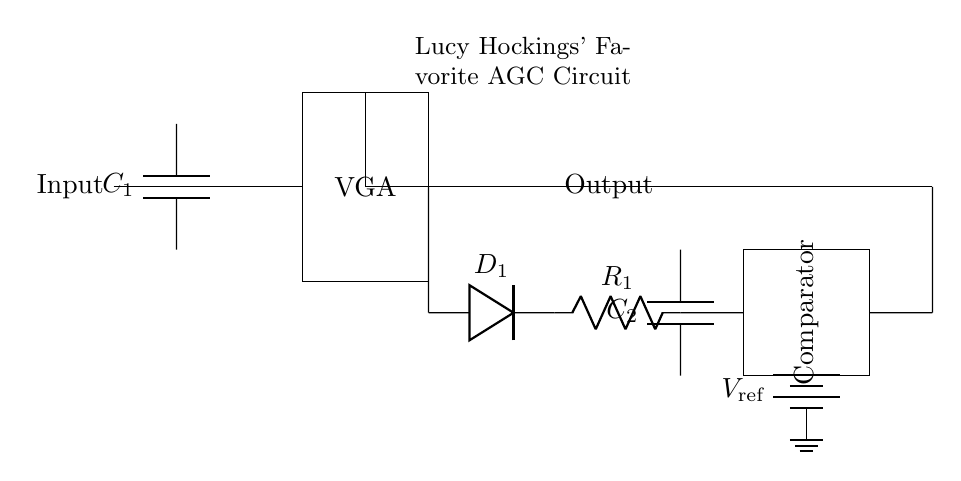What type of circuit is depicted? The circuit is an automatic gain control circuit, which is indicated by the variable gain amplifier and the feedback mechanisms present in the diagram.
Answer: Automatic gain control circuit What component is used to filter the signal? The component used for filtering the signal is a capacitor. In the circuit, the capacitor labeled C1 is connected in parallel with the input to help manage signal levels.
Answer: Capacitor How many main components are depicted in the circuit diagram? The circuit consists of six main components including: an input, a variable gain amplifier, a detector, an RC filter, a comparator, and a reference voltage source.
Answer: Six What is the function of the variable gain amplifier in this circuit? The function of the variable gain amplifier, marked as VGA, is to adjust the input signal's gain dynamically, enabling the circuit to maintain consistent output signal levels despite fluctuations in input signal strength.
Answer: Adjust gain Which component is used to detect the envelope of the signal? The component utilized to detect the envelope of the signal is the diode labeled D1 in the circuit. It facilitates the rectification process needed for envelope detection.
Answer: Diode What type of feedback mechanism is present in the circuit? The feedback mechanism in the circuit is negative feedback as indicated by the connection from the comparator output back to the variable gain amplifier, ensuring stability and consistent output.
Answer: Negative feedback What is the purpose of the reference voltage in the circuit? The purpose of the reference voltage, denoted by V reference, is to set a threshold level for the comparator, allowing it to determine when to adjust the variable gain amplifier based on the detected signal level.
Answer: Set threshold 